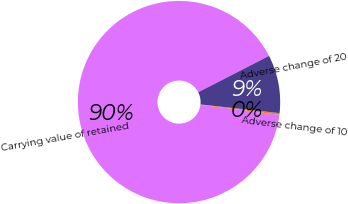Convert chart. <chart><loc_0><loc_0><loc_500><loc_500><pie_chart><fcel>Carrying value of retained<fcel>Adverse change of 10<fcel>Adverse change of 20<nl><fcel>90.45%<fcel>0.27%<fcel>9.29%<nl></chart> 